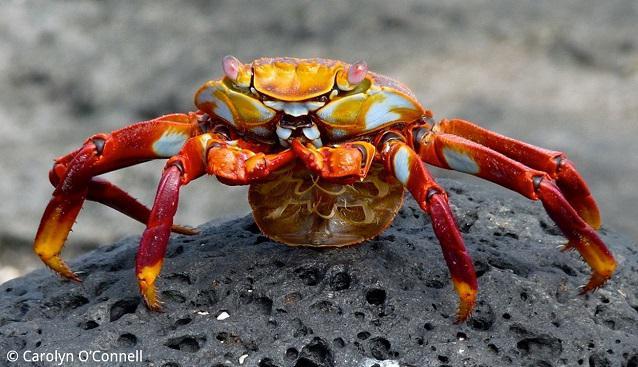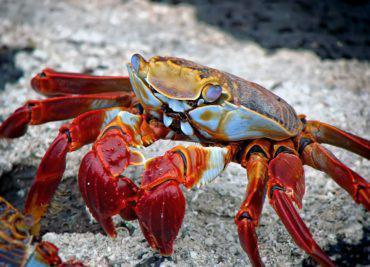The first image is the image on the left, the second image is the image on the right. Assess this claim about the two images: "The left and right image contains the same number of crabs standing on land.". Correct or not? Answer yes or no. Yes. 